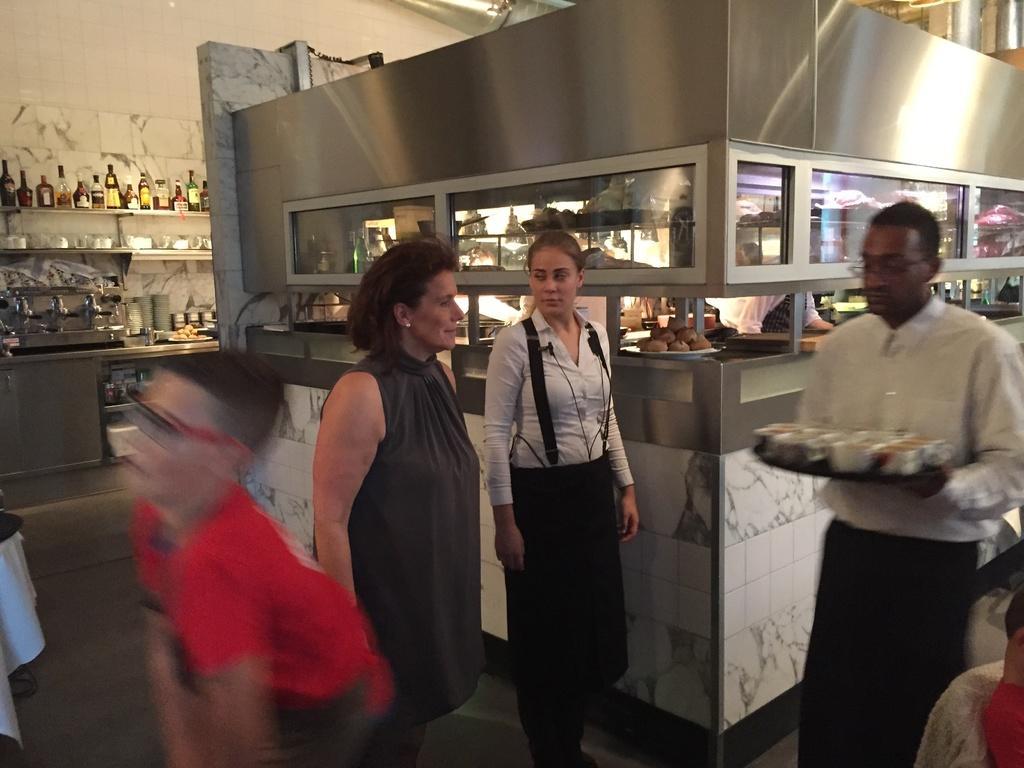Can you describe this image briefly? This picture is an inside view of a kitchen. In the center of the image we can see some persons are standing. On the right side of the image we can see a man is walking and holding a tray which consists of cups. In the background of the image we can see the wall, shelves. In shelves we can see the bottles, cups, vessels, food items. At the bottom of the image we can see the floor. 